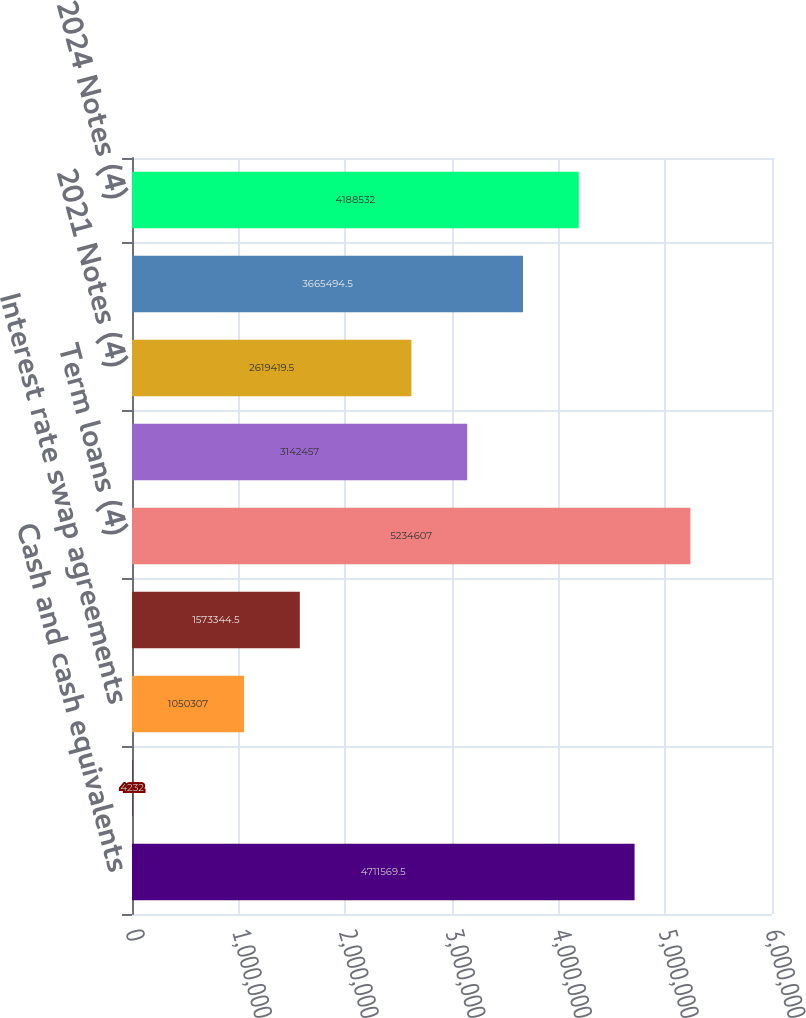Convert chart. <chart><loc_0><loc_0><loc_500><loc_500><bar_chart><fcel>Cash and cash equivalents<fcel>Interest rate cap agreements<fcel>Interest rate swap agreements<fcel>Short-term borrowings-trade<fcel>Term loans (4)<fcel>2020 Notes (4)<fcel>2021 Notes (4)<fcel>2022 Notes (4)<fcel>2024 Notes (4)<nl><fcel>4.71157e+06<fcel>4232<fcel>1.05031e+06<fcel>1.57334e+06<fcel>5.23461e+06<fcel>3.14246e+06<fcel>2.61942e+06<fcel>3.66549e+06<fcel>4.18853e+06<nl></chart> 